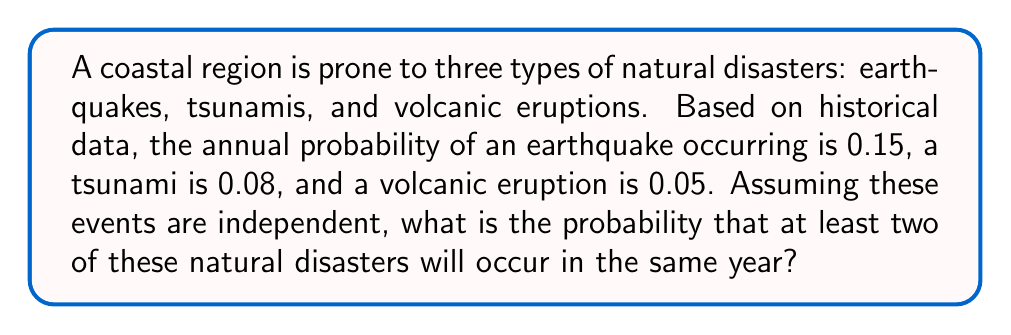Solve this math problem. Let's approach this step-by-step:

1) First, we need to calculate the probability of at least two disasters occurring. It's easier to calculate the complement of this event (i.e., the probability of 0 or 1 disaster occurring) and then subtract from 1.

2) Let's define our events:
   E: Earthquake occurs
   T: Tsunami occurs
   V: Volcanic eruption occurs

3) We know:
   P(E) = 0.15
   P(T) = 0.08
   P(V) = 0.05

4) The probability of no disasters occurring:
   P(no disasters) = (1 - P(E)) * (1 - P(T)) * (1 - P(V))
                   = (1 - 0.15) * (1 - 0.08) * (1 - 0.05)
                   = 0.85 * 0.92 * 0.95
                   = 0.7429

5) The probability of exactly one disaster occurring:
   P(only E) = P(E) * (1 - P(T)) * (1 - P(V)) = 0.15 * 0.92 * 0.95 = 0.1311
   P(only T) = (1 - P(E)) * P(T) * (1 - P(V)) = 0.85 * 0.08 * 0.95 = 0.0646
   P(only V) = (1 - P(E)) * (1 - P(T)) * P(V) = 0.85 * 0.92 * 0.05 = 0.0391

   P(exactly one disaster) = P(only E) + P(only T) + P(only V)
                           = 0.1311 + 0.0646 + 0.0391
                           = 0.2348

6) Therefore, the probability of 0 or 1 disaster occurring is:
   P(0 or 1 disaster) = P(no disasters) + P(exactly one disaster)
                      = 0.7429 + 0.2348
                      = 0.9777

7) Finally, the probability of at least two disasters occurring is:
   P(at least two disasters) = 1 - P(0 or 1 disaster)
                             = 1 - 0.9777
                             = 0.0223
Answer: 0.0223 or approximately 2.23% 